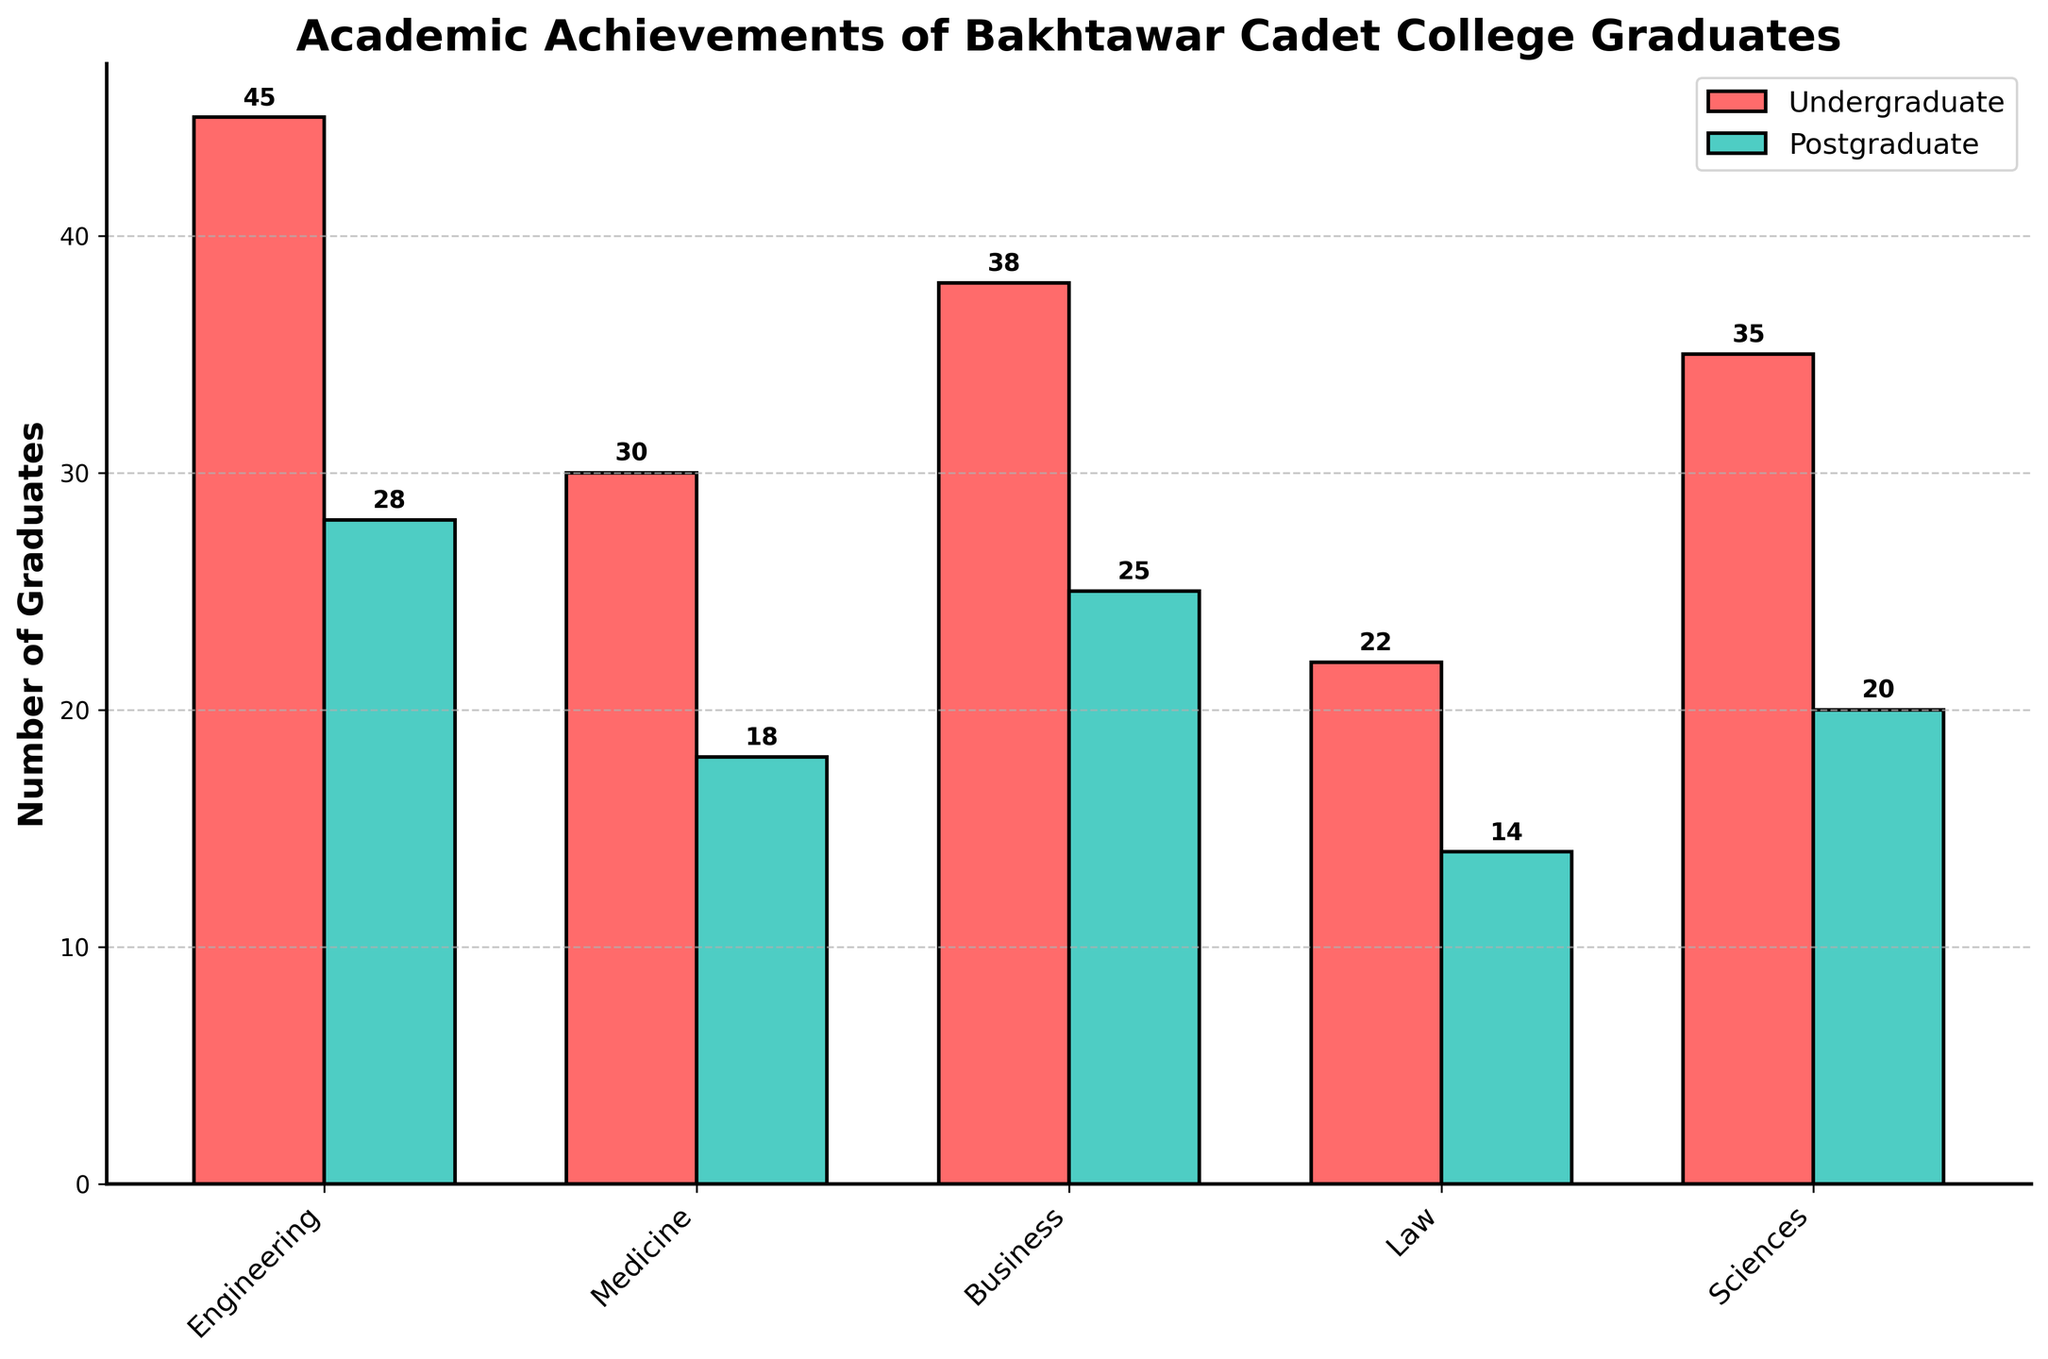Which field has the highest number of undergraduate graduates? From the chart, the tallest bar among the undergraduate graduates is for Engineering. This indicates the highest number of undergraduate graduates in this field.
Answer: Engineering Which degree level has more graduates in the field of Law? The height of the bar representing the Law field for undergraduate graduates is higher than that for postgraduate graduates.
Answer: Undergraduate What is the total number of graduates in the Sciences field for both degree levels combined? The number of undergraduate graduates in Sciences is 35, and postgraduate graduates in Sciences is 20. Adding them together gives 35 + 20 = 55.
Answer: 55 In which field is the difference between the number of undergraduate and postgraduate graduates the largest? In the chart, looking at each field, the difference between undergraduate and postgraduate graduates for Engineering is 45 - 28 = 17, which is the largest compared to other fields.
Answer: Engineering What is the average number of postgraduate graduates across all fields? Summing the number of postgraduate graduates in all fields: 28 (Engineering) + 18 (Medicine) + 25 (Business) + 14 (Law) + 20 (Sciences) = 105. There are 5 fields, so 105 / 5 = 21.
Answer: 21 How many more undergraduate graduates are there compared to postgraduate graduates in the Medicine field? The number of undergraduate graduates in Medicine is 30 and postgraduate graduates is 18. The difference is 30 - 18 = 12.
Answer: 12 Which field has the least number of undergraduate graduates? The shortest bar among the undergraduate graduates is for Law, indicating the least number of graduates in this field.
Answer: Law What's the ratio of undergraduate to postgraduate graduates in Business? The number of undergraduate graduates in Business is 38, and postgraduate graduates is 25. The ratio 38:25 can be simplified by dividing both numbers by their greatest common divisor, which is 1. So, the ratio remains 38:25.
Answer: 38:25 